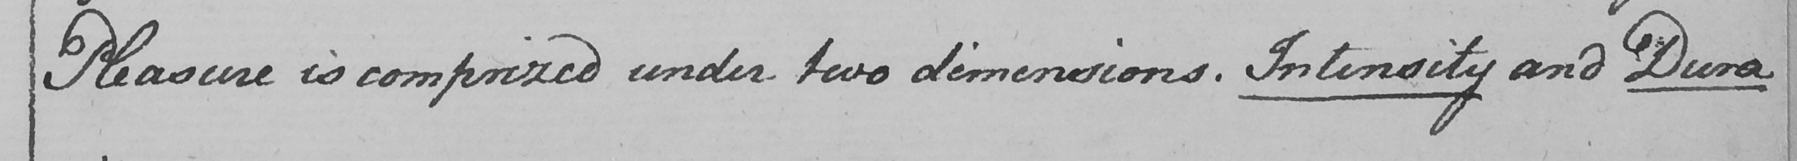What does this handwritten line say? Pleasure is comprised under two dimensions . Intensity and Dura 